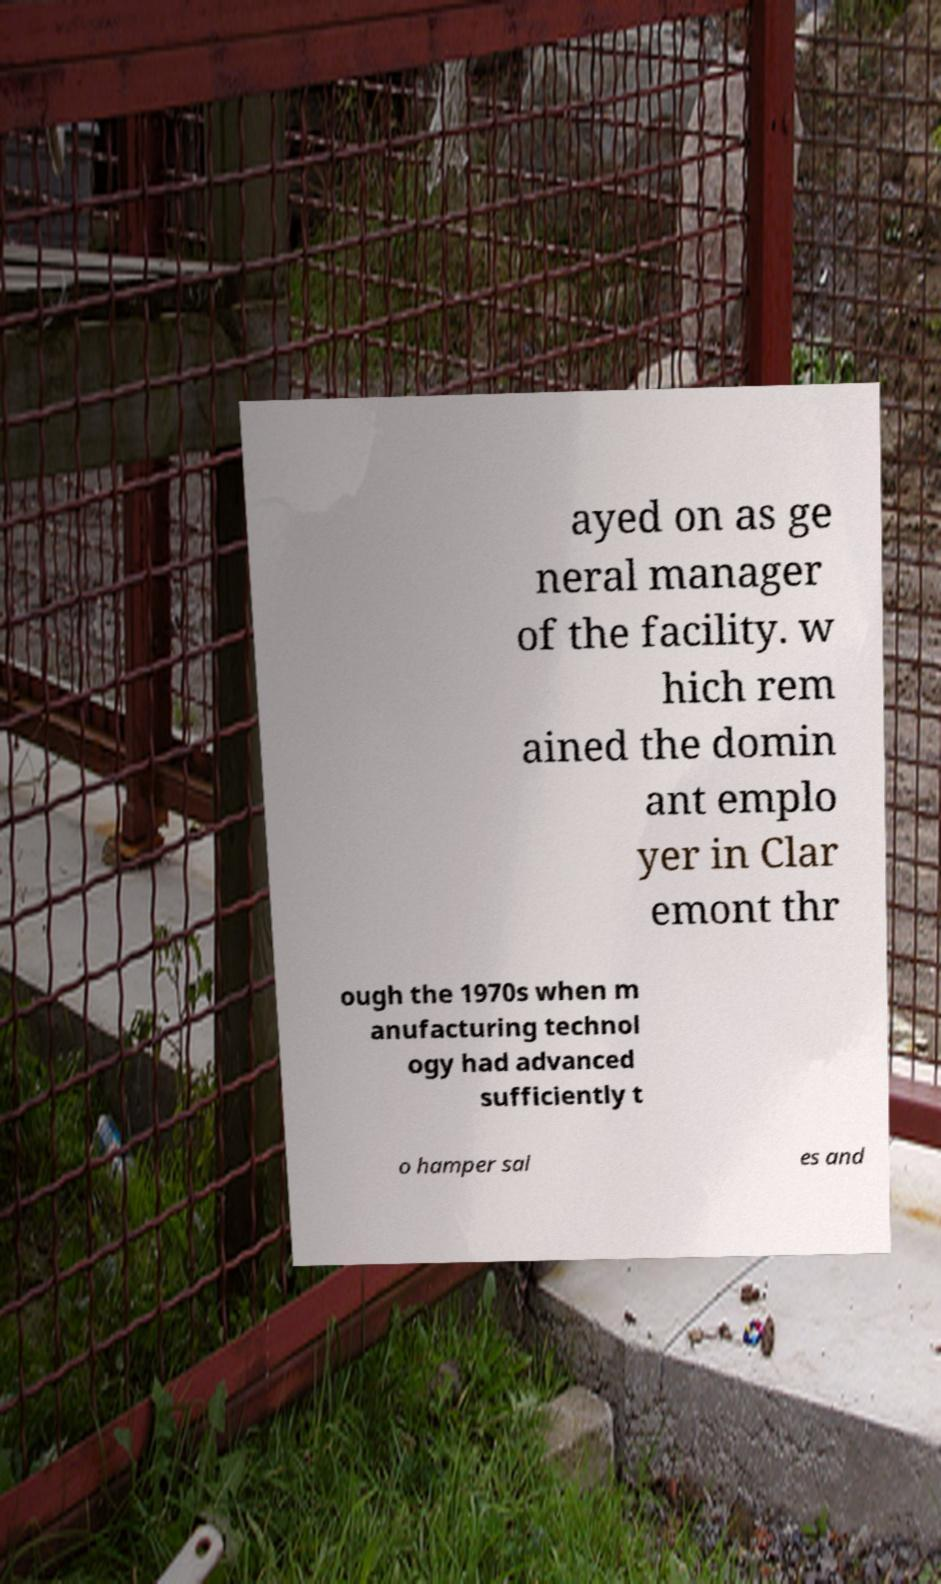Can you accurately transcribe the text from the provided image for me? ayed on as ge neral manager of the facility. w hich rem ained the domin ant emplo yer in Clar emont thr ough the 1970s when m anufacturing technol ogy had advanced sufficiently t o hamper sal es and 